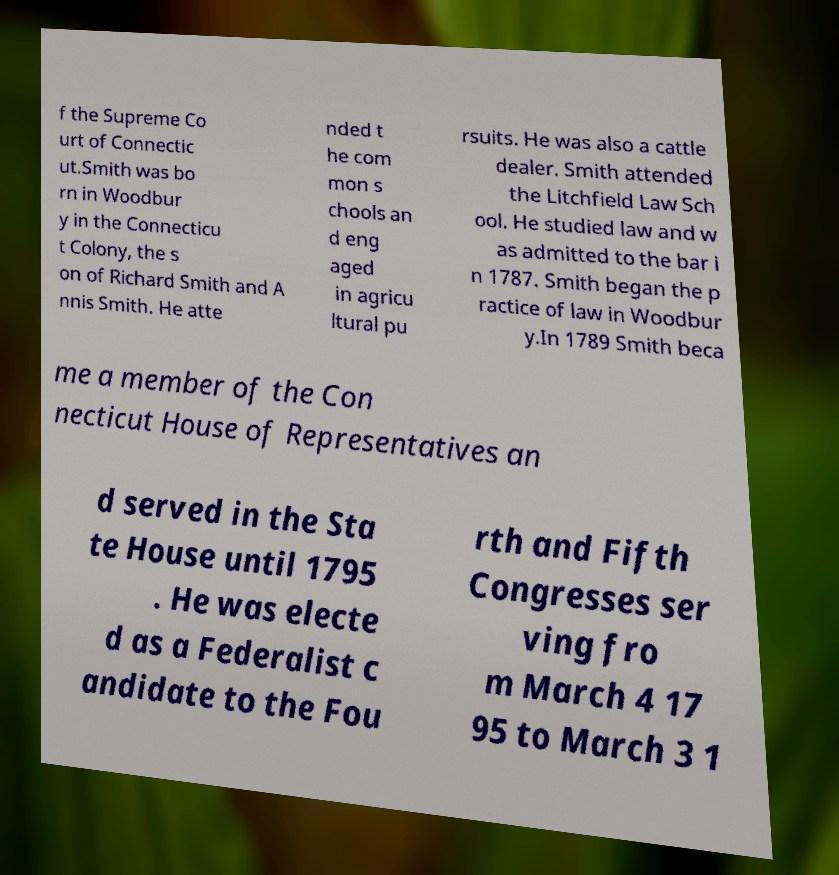Can you accurately transcribe the text from the provided image for me? f the Supreme Co urt of Connectic ut.Smith was bo rn in Woodbur y in the Connecticu t Colony, the s on of Richard Smith and A nnis Smith. He atte nded t he com mon s chools an d eng aged in agricu ltural pu rsuits. He was also a cattle dealer. Smith attended the Litchfield Law Sch ool. He studied law and w as admitted to the bar i n 1787. Smith began the p ractice of law in Woodbur y.In 1789 Smith beca me a member of the Con necticut House of Representatives an d served in the Sta te House until 1795 . He was electe d as a Federalist c andidate to the Fou rth and Fifth Congresses ser ving fro m March 4 17 95 to March 3 1 